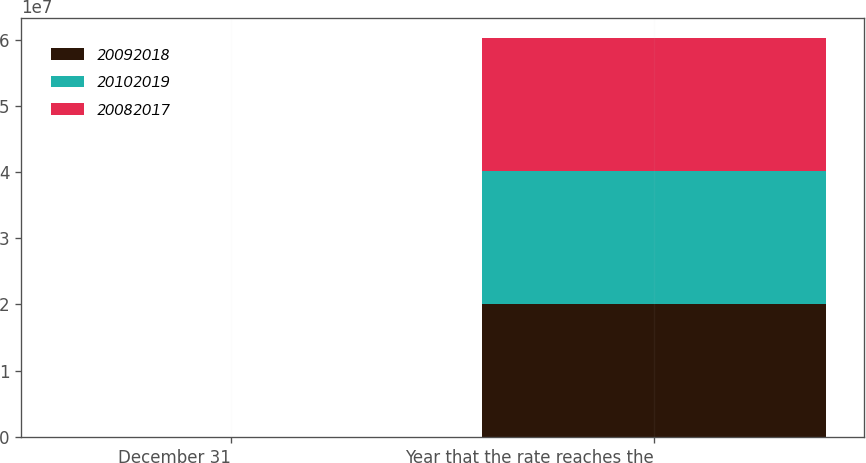Convert chart. <chart><loc_0><loc_0><loc_500><loc_500><stacked_bar_chart><ecel><fcel>December 31<fcel>Year that the rate reaches the<nl><fcel>2.0092e+07<fcel>2009<fcel>2.0102e+07<nl><fcel>2.0102e+07<fcel>2008<fcel>2.0092e+07<nl><fcel>2.0082e+07<fcel>2007<fcel>2.0082e+07<nl></chart> 